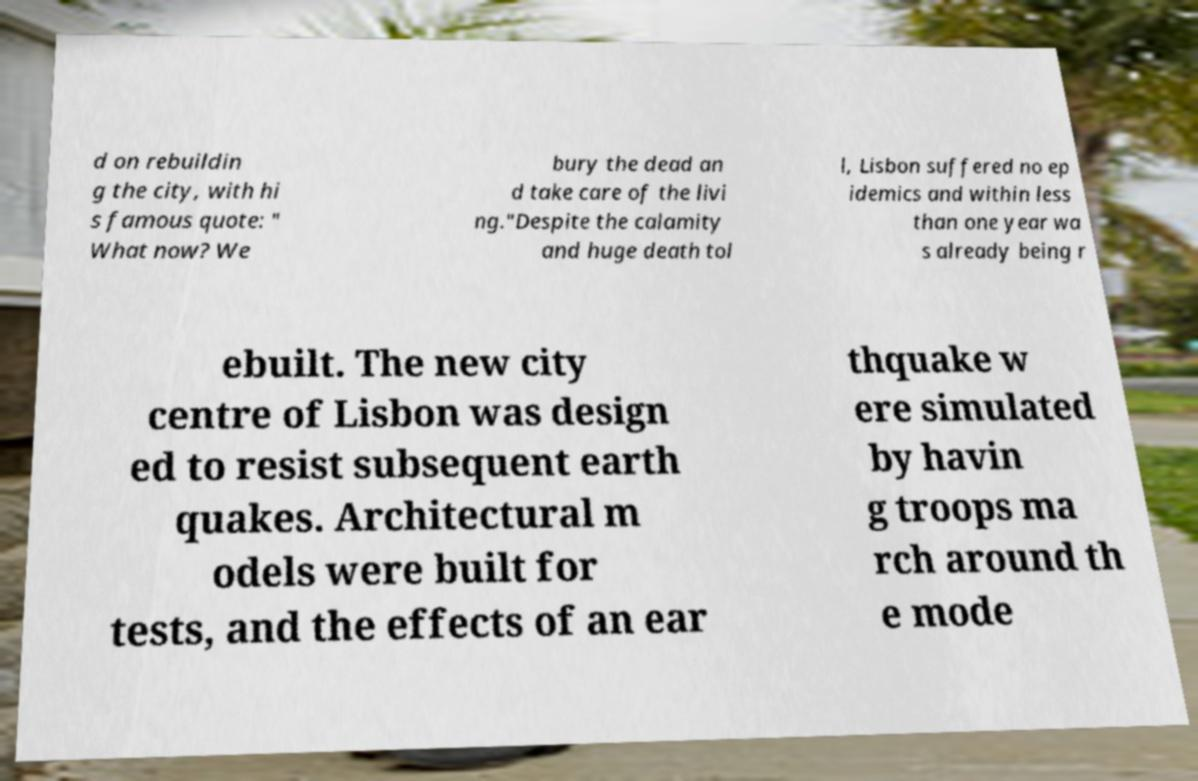Please read and relay the text visible in this image. What does it say? d on rebuildin g the city, with hi s famous quote: " What now? We bury the dead an d take care of the livi ng."Despite the calamity and huge death tol l, Lisbon suffered no ep idemics and within less than one year wa s already being r ebuilt. The new city centre of Lisbon was design ed to resist subsequent earth quakes. Architectural m odels were built for tests, and the effects of an ear thquake w ere simulated by havin g troops ma rch around th e mode 